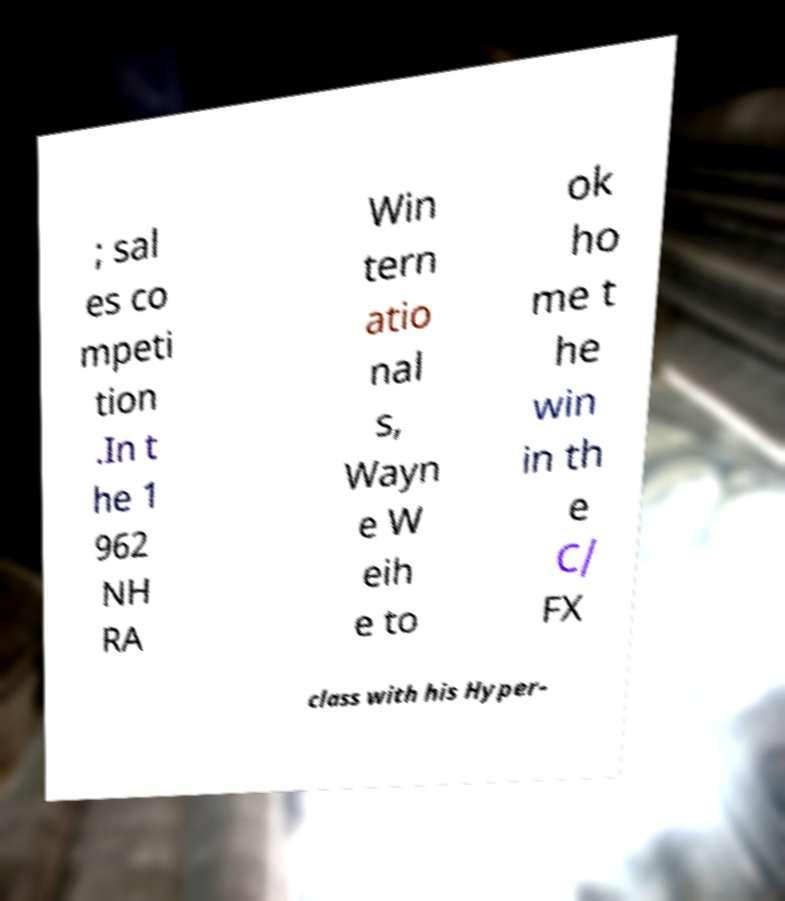I need the written content from this picture converted into text. Can you do that? ; sal es co mpeti tion .In t he 1 962 NH RA Win tern atio nal s, Wayn e W eih e to ok ho me t he win in th e C/ FX class with his Hyper- 